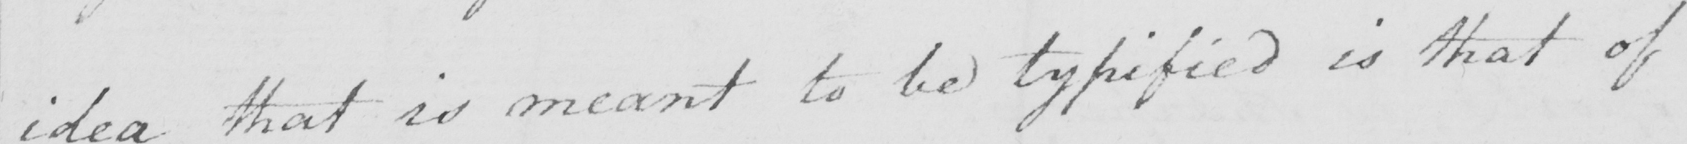Transcribe the text shown in this historical manuscript line. idea that is meant to be typified is that of 